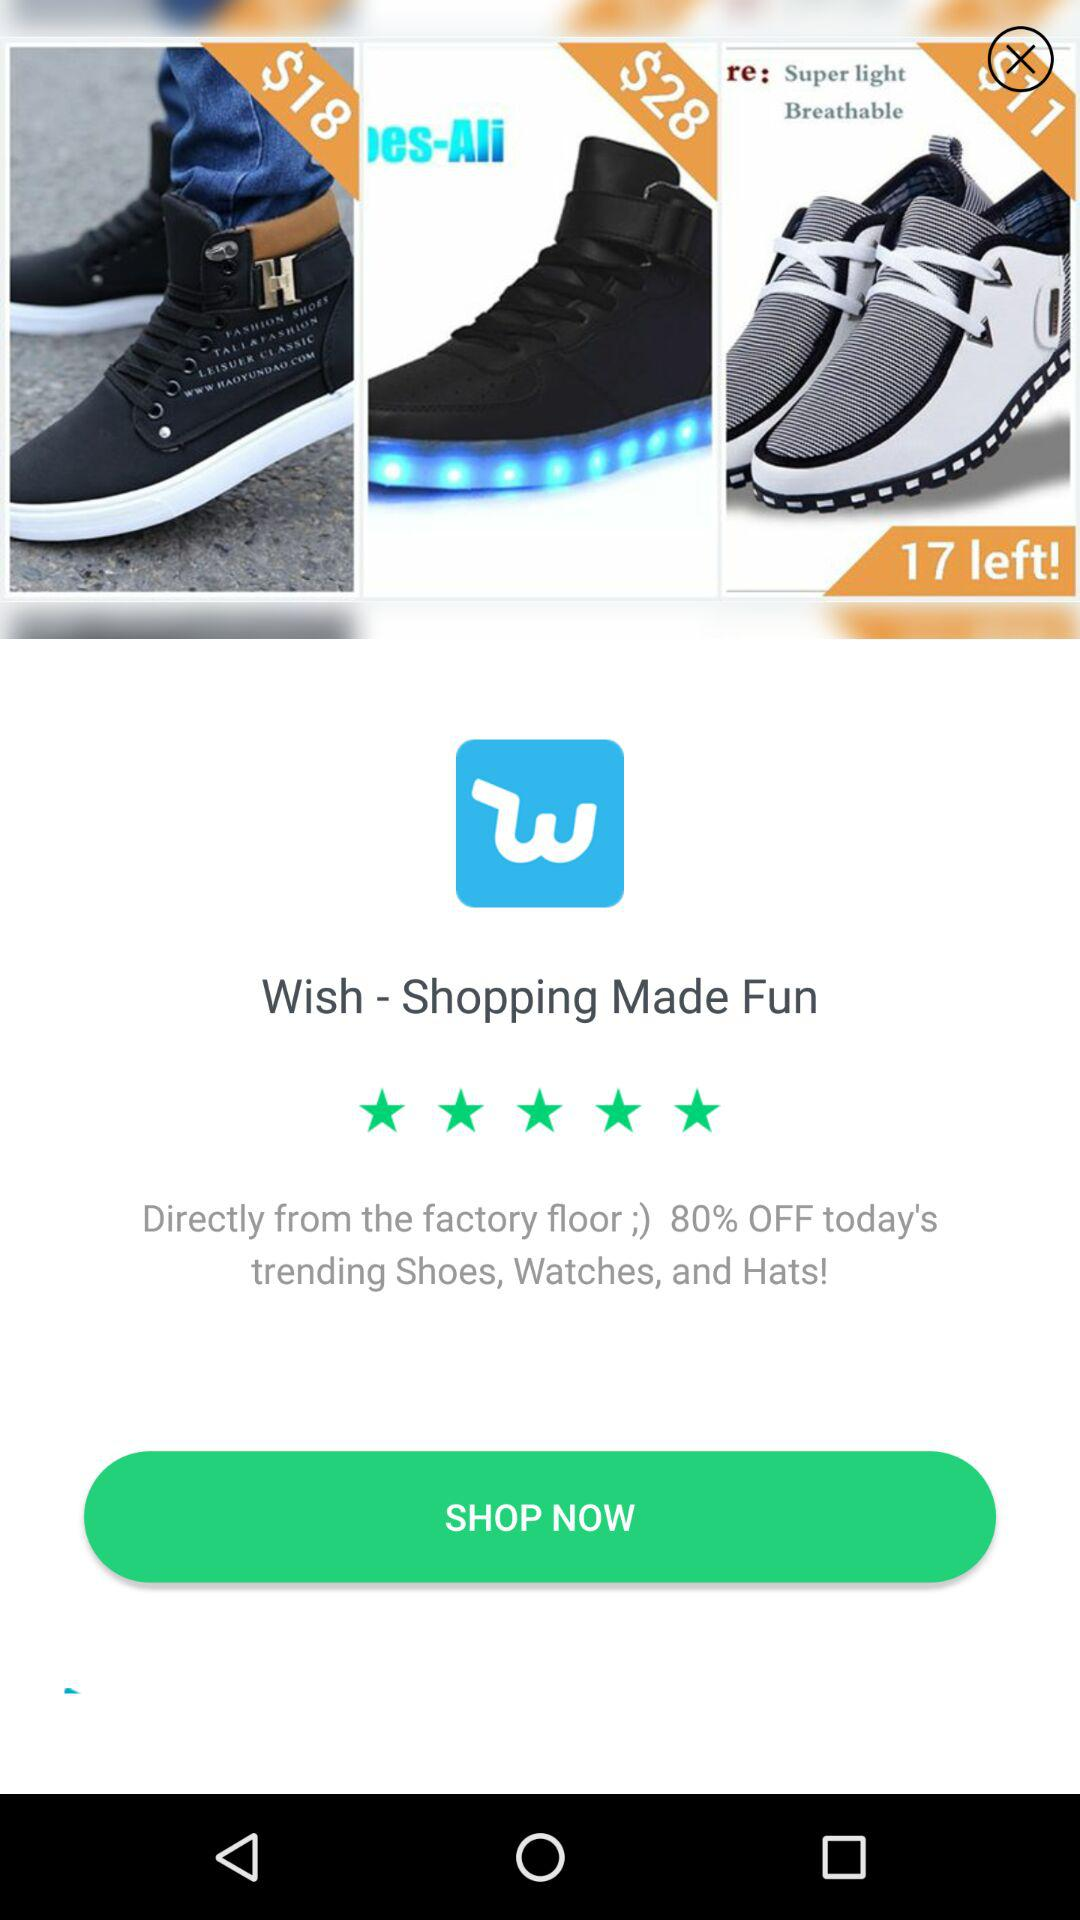What is the application name? The application name is "Wish - Shopping Made Fun". 